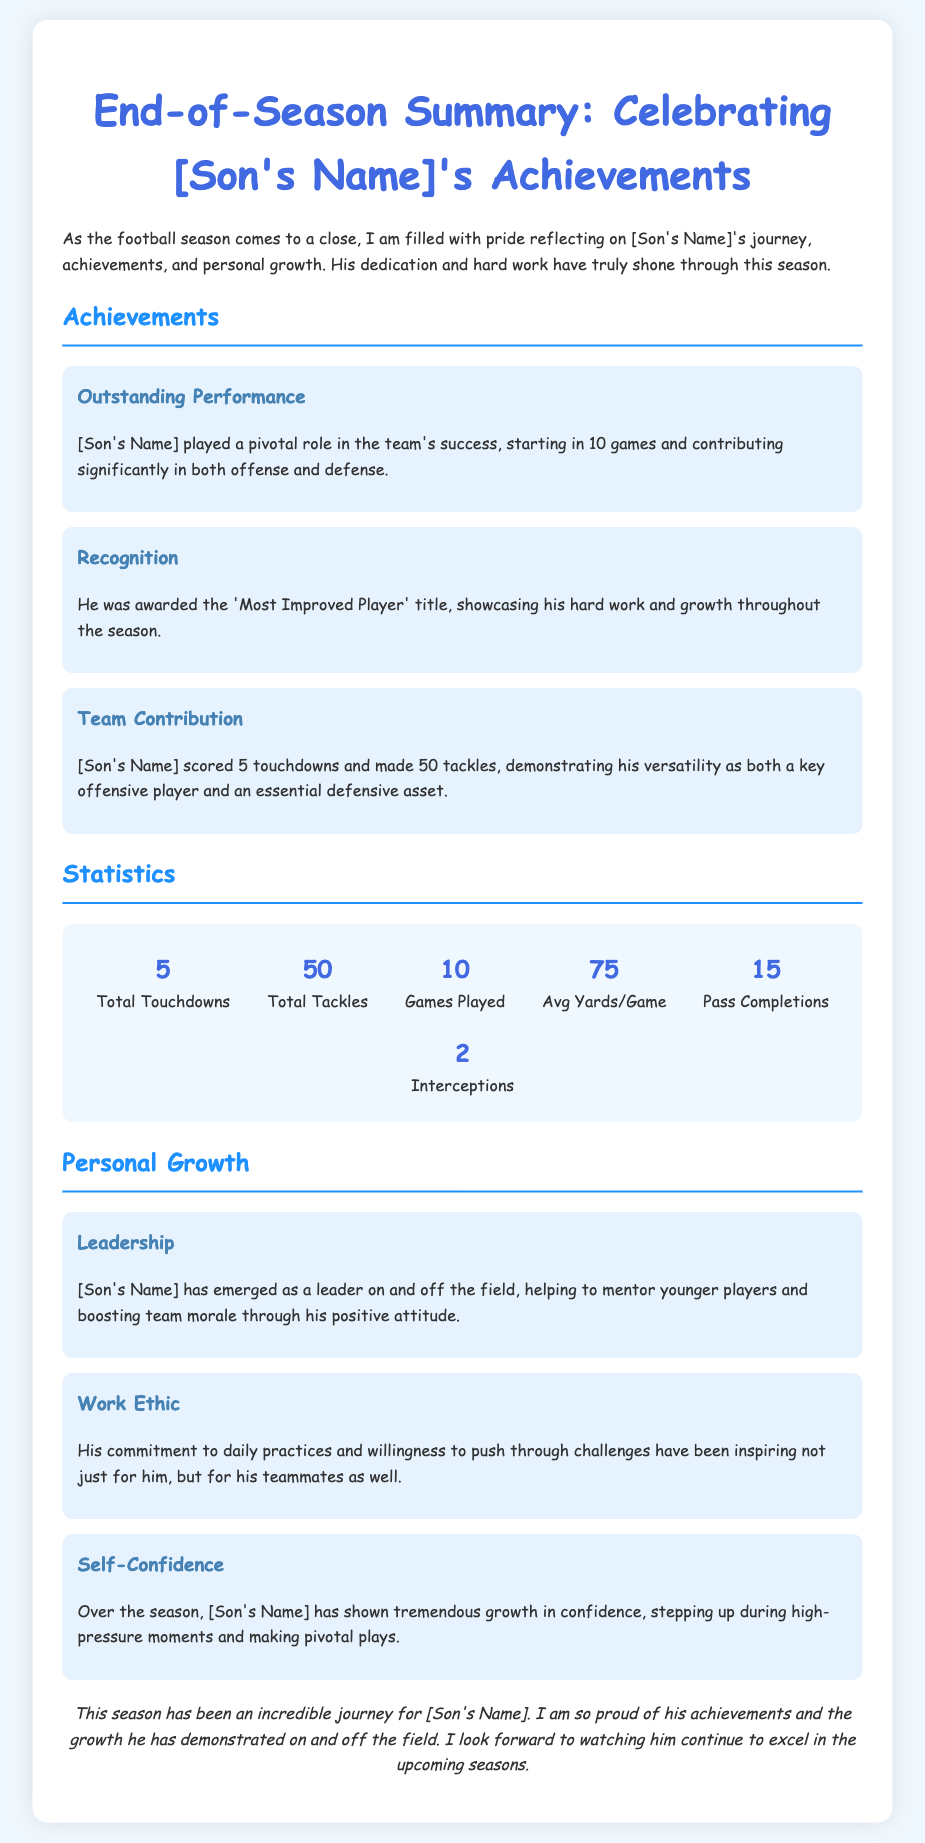What was the total number of touchdowns scored by [Son's Name]? The total touchdowns scored by [Son's Name] is mentioned in the statistics section as 5.
Answer: 5 How many games did [Son's Name] play this season? The total games played by [Son's Name] is stated in the statistics as 10.
Answer: 10 What recognition did [Son's Name] receive this season? The document states he was awarded the 'Most Improved Player' title for his growth.
Answer: Most Improved Player What is [Son's Name]'s average yards per game? The average yards per game for [Son's Name] is listed in the statistics as 75.
Answer: 75 What is mentioned about [Son's Name]'s leadership? The document highlights that [Son's Name] has emerged as a leader, helping mentor younger players.
Answer: A leader How many tackles did [Son's Name] make? The document states that he made a total of 50 tackles this season according to the statistics.
Answer: 50 What aspect of personal growth is emphasized regarding work ethic? The note describes his commitment to daily practices and pushing through challenges.
Answer: Commitment What significant role did [Son's Name] play in the team's success? He played a pivotal role by starting in 10 games, significant in both offense and defense.
Answer: Pivotal role What does the conclusion reflect about [Son's Name]'s journey this season? The conclusion expresses pride in [Son's Name]'s achievements and growth on and off the field.
Answer: Pride in achievements 